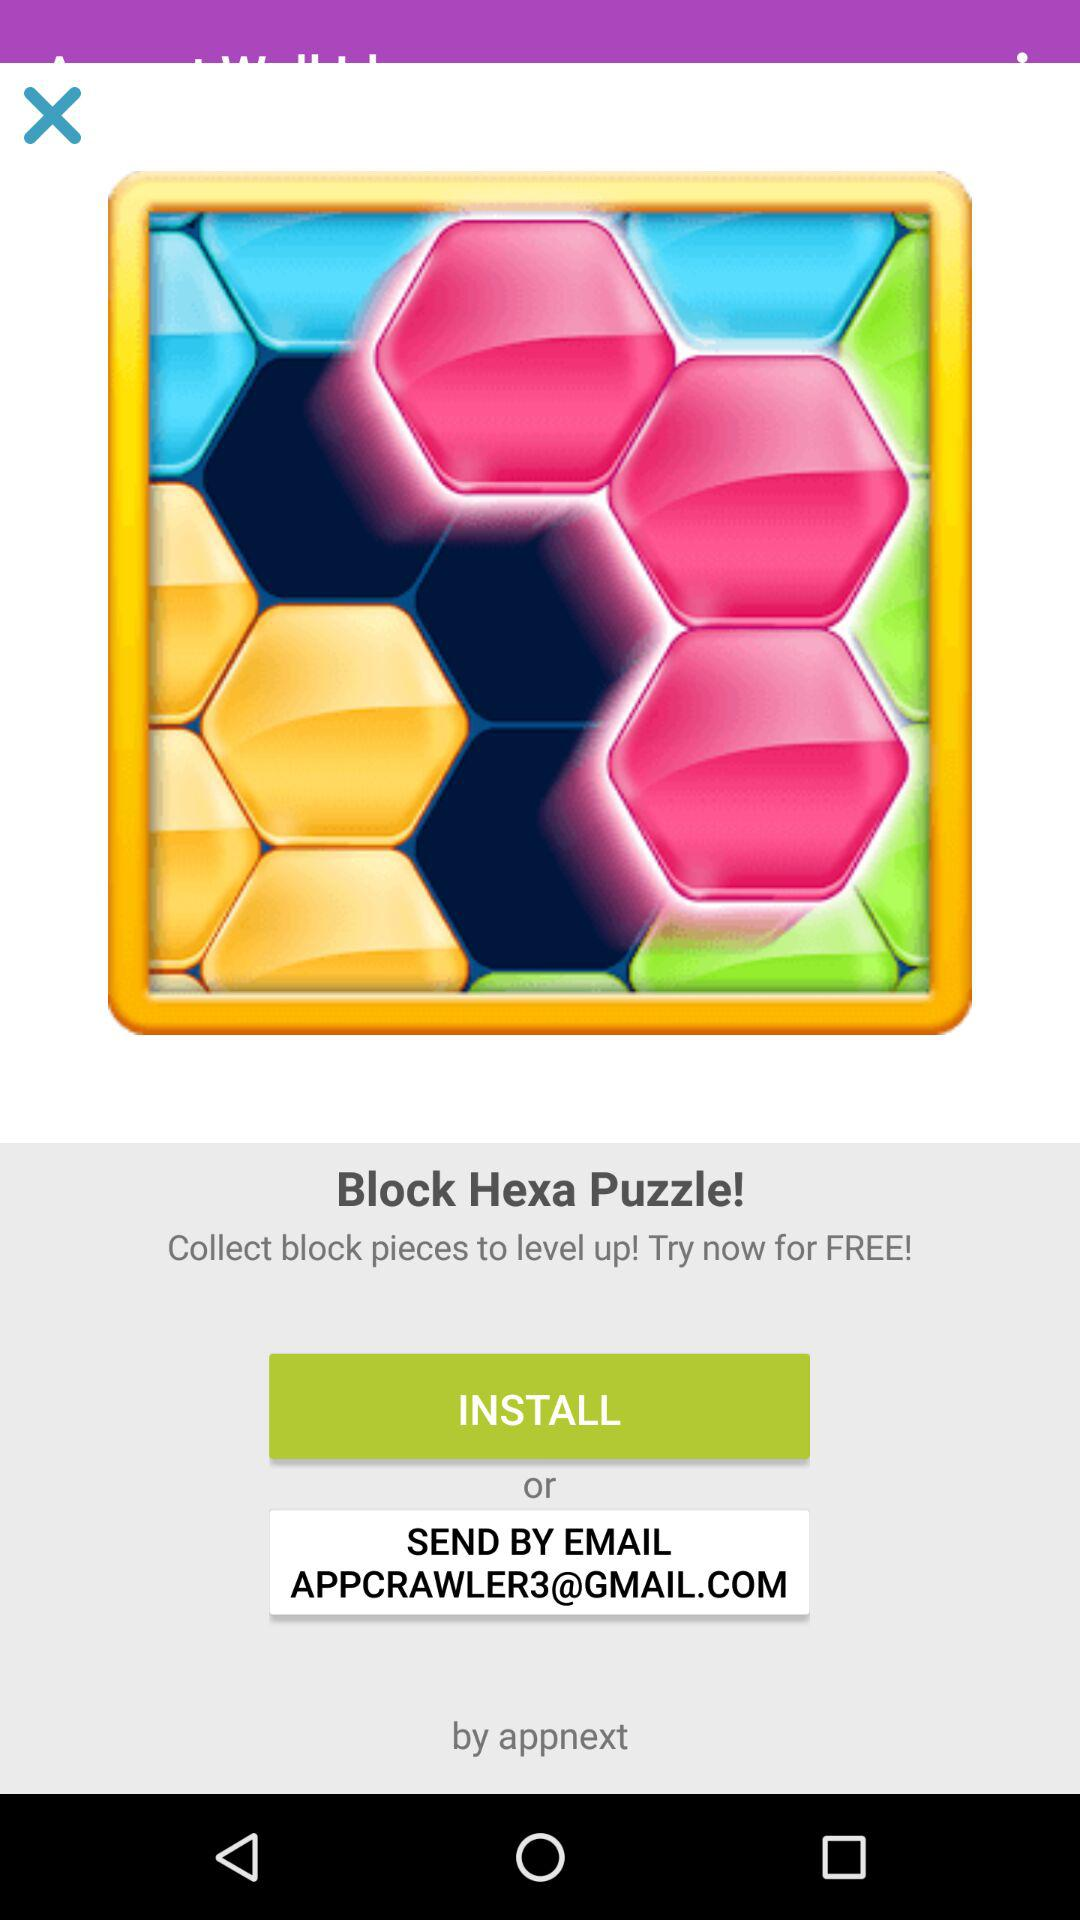How to level up the game? To level up the game, collect block pieces. 